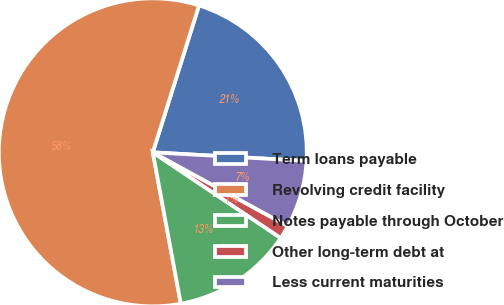Convert chart to OTSL. <chart><loc_0><loc_0><loc_500><loc_500><pie_chart><fcel>Term loans payable<fcel>Revolving credit facility<fcel>Notes payable through October<fcel>Other long-term debt at<fcel>Less current maturities<nl><fcel>21.04%<fcel>57.77%<fcel>12.7%<fcel>1.43%<fcel>7.07%<nl></chart> 